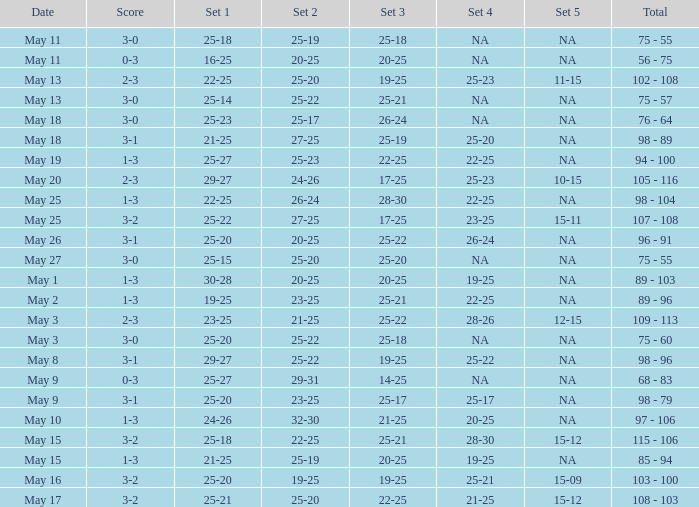Give me the full table as a dictionary. {'header': ['Date', 'Score', 'Set 1', 'Set 2', 'Set 3', 'Set 4', 'Set 5', 'Total'], 'rows': [['May 11', '3-0', '25-18', '25-19', '25-18', 'NA', 'NA', '75 - 55'], ['May 11', '0-3', '16-25', '20-25', '20-25', 'NA', 'NA', '56 - 75'], ['May 13', '2-3', '22-25', '25-20', '19-25', '25-23', '11-15', '102 - 108'], ['May 13', '3-0', '25-14', '25-22', '25-21', 'NA', 'NA', '75 - 57'], ['May 18', '3-0', '25-23', '25-17', '26-24', 'NA', 'NA', '76 - 64'], ['May 18', '3-1', '21-25', '27-25', '25-19', '25-20', 'NA', '98 - 89'], ['May 19', '1-3', '25-27', '25-23', '22-25', '22-25', 'NA', '94 - 100'], ['May 20', '2-3', '29-27', '24-26', '17-25', '25-23', '10-15', '105 - 116'], ['May 25', '1-3', '22-25', '26-24', '28-30', '22-25', 'NA', '98 - 104'], ['May 25', '3-2', '25-22', '27-25', '17-25', '23-25', '15-11', '107 - 108'], ['May 26', '3-1', '25-20', '20-25', '25-22', '26-24', 'NA', '96 - 91'], ['May 27', '3-0', '25-15', '25-20', '25-20', 'NA', 'NA', '75 - 55'], ['May 1', '1-3', '30-28', '20-25', '20-25', '19-25', 'NA', '89 - 103'], ['May 2', '1-3', '19-25', '23-25', '25-21', '22-25', 'NA', '89 - 96'], ['May 3', '2-3', '23-25', '21-25', '25-22', '28-26', '12-15', '109 - 113'], ['May 3', '3-0', '25-20', '25-22', '25-18', 'NA', 'NA', '75 - 60'], ['May 8', '3-1', '29-27', '25-22', '19-25', '25-22', 'NA', '98 - 96'], ['May 9', '0-3', '25-27', '29-31', '14-25', 'NA', 'NA', '68 - 83'], ['May 9', '3-1', '25-20', '23-25', '25-17', '25-17', 'NA', '98 - 79'], ['May 10', '1-3', '24-26', '32-30', '21-25', '20-25', 'NA', '97 - 106'], ['May 15', '3-2', '25-18', '22-25', '25-21', '28-30', '15-12', '115 - 106'], ['May 15', '1-3', '21-25', '25-19', '20-25', '19-25', 'NA', '85 - 94'], ['May 16', '3-2', '25-20', '19-25', '19-25', '25-21', '15-09', '103 - 100'], ['May 17', '3-2', '25-21', '25-20', '22-25', '21-25', '15-12', '108 - 103']]} What is the set 2 the has 1 set of 21-25, and 4 sets of 25-20? 27-25. 